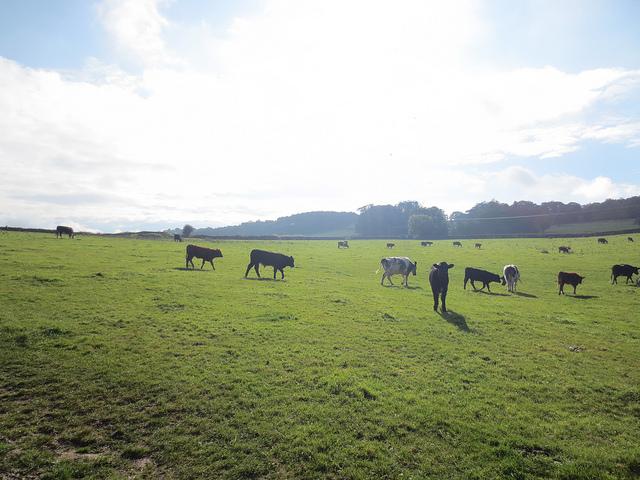Are there any cattle in this picture?
Keep it brief. Yes. Is this in the wild?
Short answer required. Yes. Is it sunny?
Concise answer only. Yes. How many dogs are in this photo?
Answer briefly. 0. What animals are these?
Be succinct. Cows. How many cows are standing?
Short answer required. 18. 